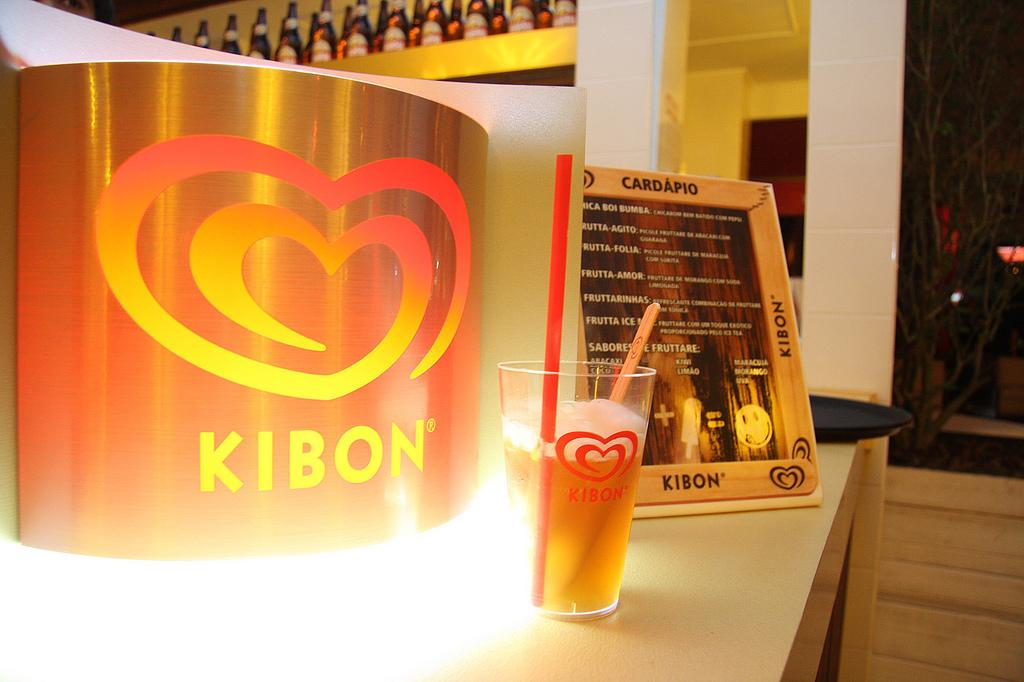What type of containers can be seen in the image? There are bottles in the image. What is the glass on the table being used for? The glass with a straw in the image is likely being used for drinking. What is written or displayed on the table? There is a frame with text on the table. What object is placed on the side of the table? There is a tray on the side of the table. What type of songs can be heard playing in the background of the image? There is no information about songs or background music in the image, so we cannot determine what songs might be playing. --- 